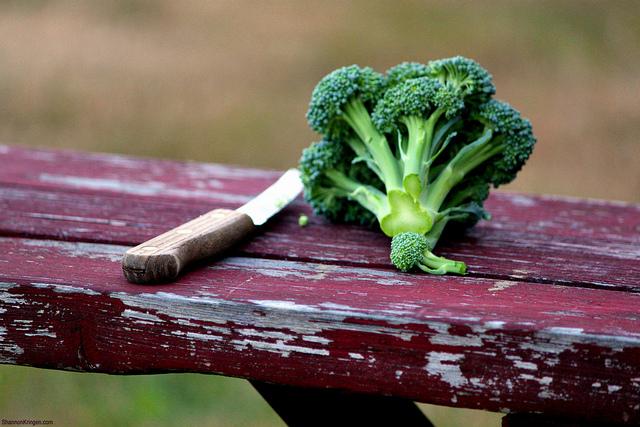Is someone cutting the broccoli?
Give a very brief answer. No. Is the broccoli cooked?
Answer briefly. No. Is this broccoli or cauliflower?
Be succinct. Broccoli. 